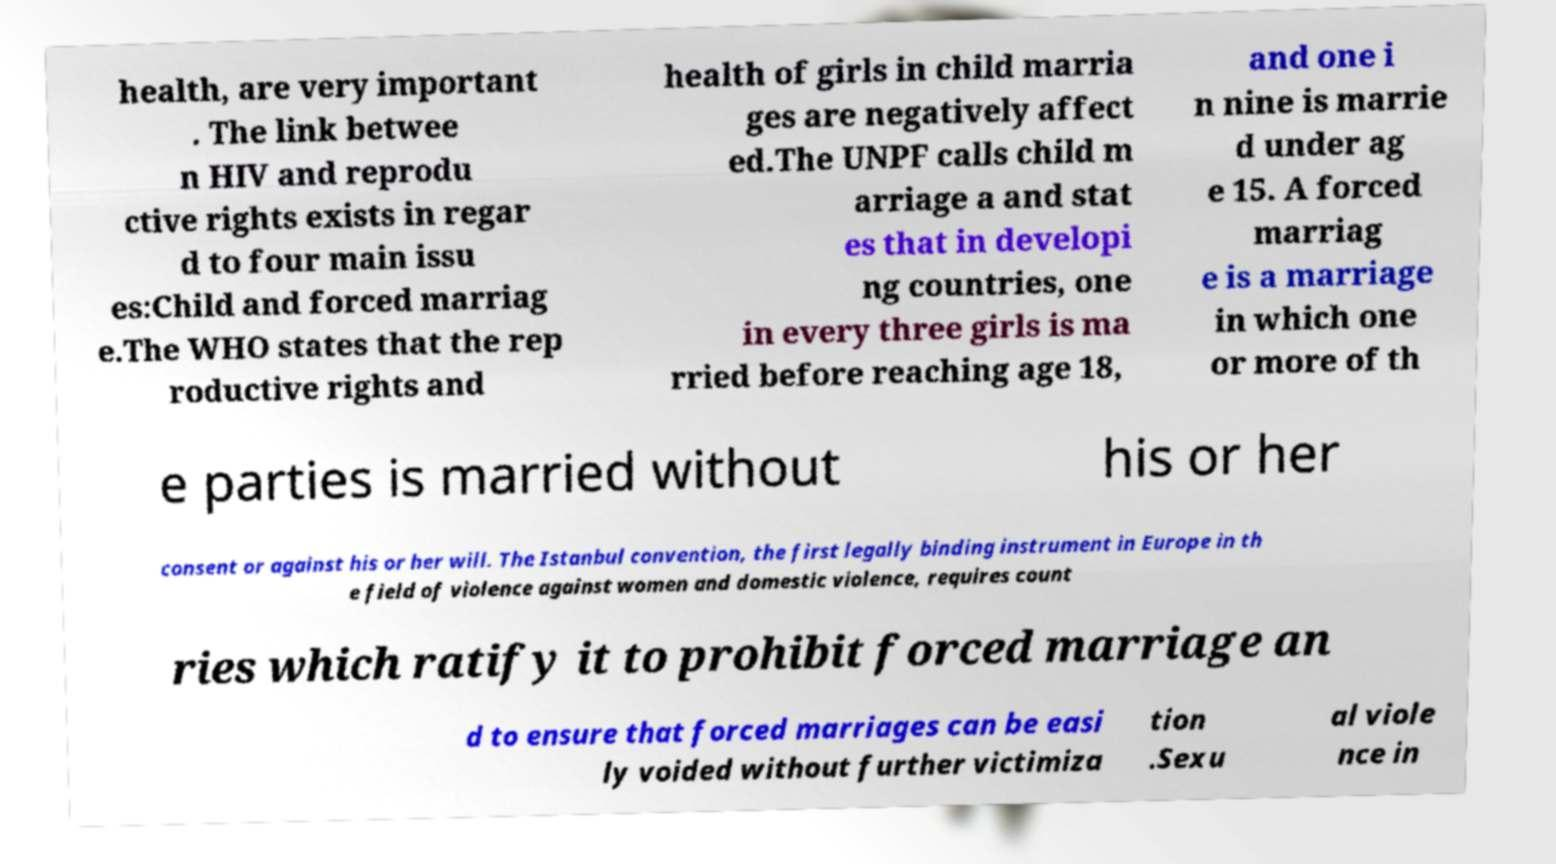Could you extract and type out the text from this image? health, are very important . The link betwee n HIV and reprodu ctive rights exists in regar d to four main issu es:Child and forced marriag e.The WHO states that the rep roductive rights and health of girls in child marria ges are negatively affect ed.The UNPF calls child m arriage a and stat es that in developi ng countries, one in every three girls is ma rried before reaching age 18, and one i n nine is marrie d under ag e 15. A forced marriag e is a marriage in which one or more of th e parties is married without his or her consent or against his or her will. The Istanbul convention, the first legally binding instrument in Europe in th e field of violence against women and domestic violence, requires count ries which ratify it to prohibit forced marriage an d to ensure that forced marriages can be easi ly voided without further victimiza tion .Sexu al viole nce in 